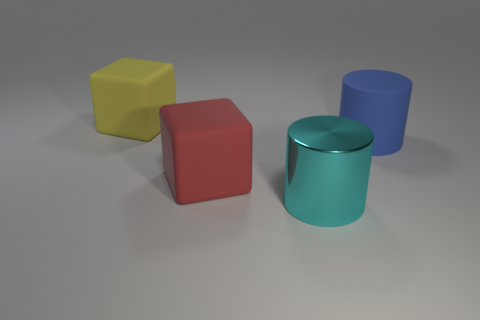Are there any other rubber objects of the same shape as the yellow object?
Keep it short and to the point. Yes. Are the cylinder behind the large cyan shiny object and the block that is in front of the blue cylinder made of the same material?
Your answer should be very brief. Yes. What number of other large cylinders have the same material as the cyan cylinder?
Offer a very short reply. 0. What color is the big rubber cylinder?
Provide a short and direct response. Blue. There is a big blue rubber object on the right side of the yellow thing; does it have the same shape as the object that is in front of the large red object?
Keep it short and to the point. Yes. There is a big cylinder right of the big cyan metallic object; what color is it?
Your answer should be very brief. Blue. Is the number of objects to the left of the metal cylinder less than the number of yellow things in front of the blue rubber thing?
Provide a short and direct response. No. What number of other things are there of the same material as the red object
Make the answer very short. 2. Does the cyan thing have the same material as the big blue object?
Offer a very short reply. No. What number of other objects are the same size as the red cube?
Your response must be concise. 3. 